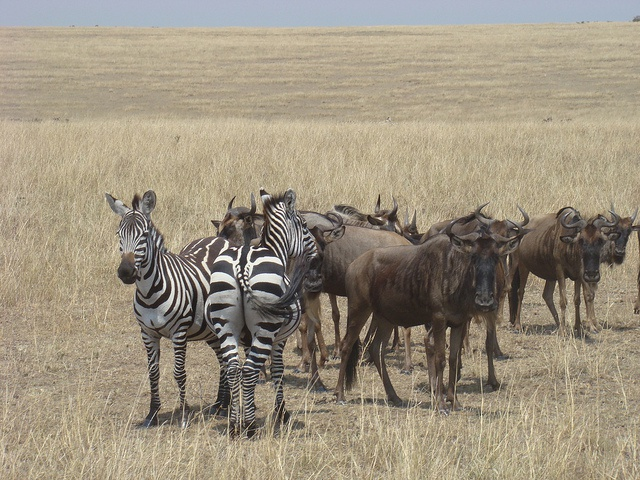Describe the objects in this image and their specific colors. I can see cow in darkgray, black, and gray tones, zebra in darkgray, gray, black, and lightgray tones, zebra in darkgray, gray, black, and lightgray tones, cow in darkgray, black, and gray tones, and cow in darkgray, gray, and black tones in this image. 